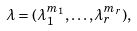<formula> <loc_0><loc_0><loc_500><loc_500>\lambda = ( \lambda _ { 1 } ^ { m _ { 1 } } , \dots , \lambda _ { r } ^ { m _ { r } } ) ,</formula> 